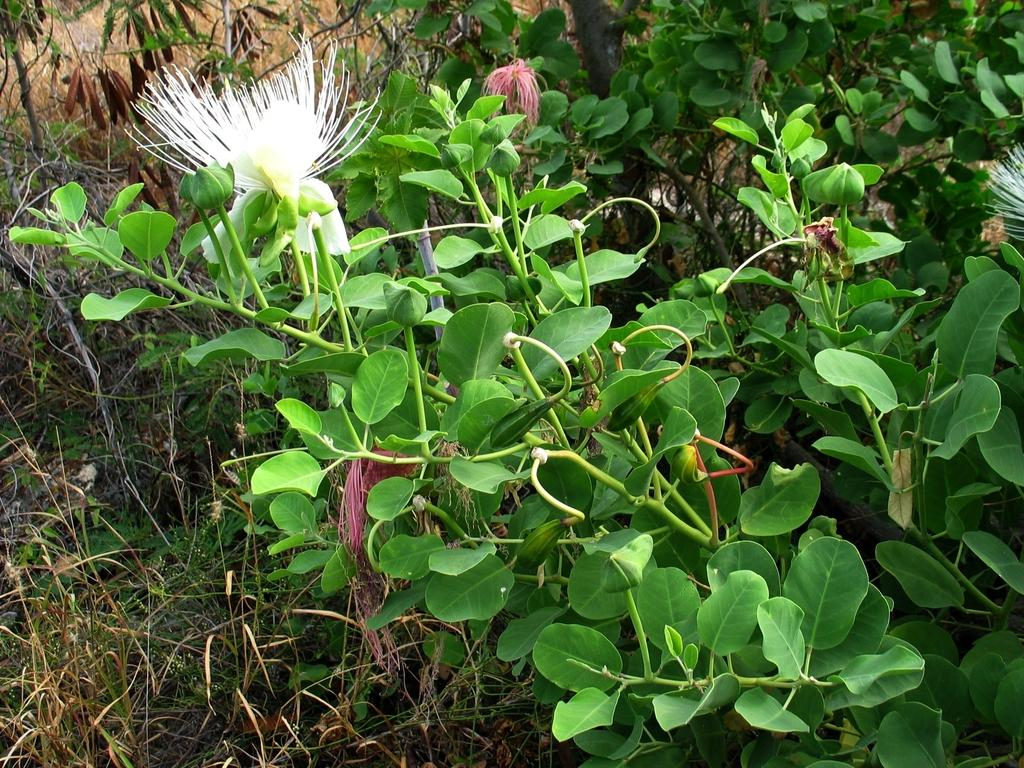What type of plants can be seen in the image? There are plants with flowers in the image. What is visible at the bottom of the image? There is grass visible at the bottom of the image. Where is the hen located in the image? There is no hen present in the image. What type of clothing accessory is visible in the image? There are no clothing accessories visible in the image. 